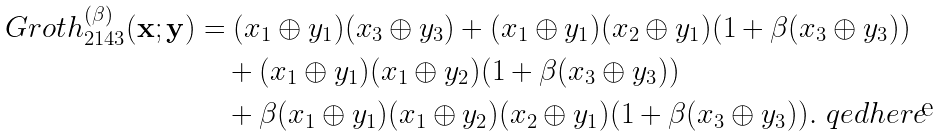Convert formula to latex. <formula><loc_0><loc_0><loc_500><loc_500>\ G r o t h ^ { ( \beta ) } _ { 2 1 4 3 } ( \mathbf x ; \mathbf y ) & = ( x _ { 1 } \oplus y _ { 1 } ) ( x _ { 3 } \oplus y _ { 3 } ) + ( x _ { 1 } \oplus y _ { 1 } ) ( x _ { 2 } \oplus y _ { 1 } ) ( 1 + \beta ( x _ { 3 } \oplus y _ { 3 } ) ) \\ & \quad + ( x _ { 1 } \oplus y _ { 1 } ) ( x _ { 1 } \oplus y _ { 2 } ) ( 1 + \beta ( x _ { 3 } \oplus y _ { 3 } ) ) \\ & \quad + \beta ( x _ { 1 } \oplus y _ { 1 } ) ( x _ { 1 } \oplus y _ { 2 } ) ( x _ { 2 } \oplus y _ { 1 } ) ( 1 + \beta ( x _ { 3 } \oplus y _ { 3 } ) ) . \ q e d h e r e</formula> 